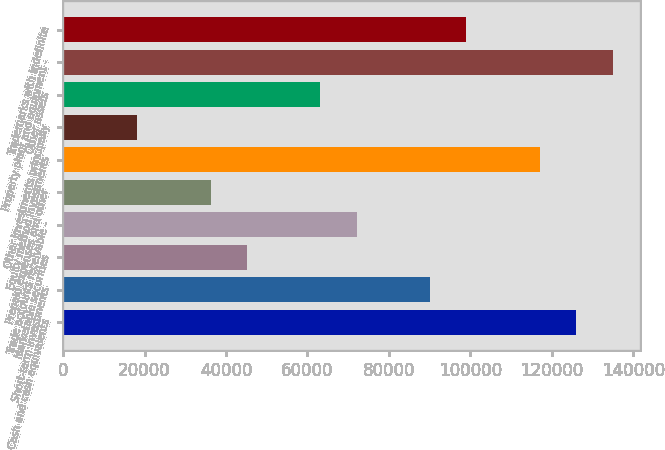<chart> <loc_0><loc_0><loc_500><loc_500><bar_chart><fcel>Cash and cash equivalents<fcel>Short-term investments<fcel>Marketable securities<fcel>Trade accounts receivable -<fcel>Prepaid expenses and other<fcel>Equity method investments<fcel>Other investments principally<fcel>Other assets<fcel>Property plant and equipment -<fcel>Trademarks with indefinite<nl><fcel>125953<fcel>90055<fcel>45182<fcel>72105.8<fcel>36207.4<fcel>116979<fcel>18258.2<fcel>63131.2<fcel>134928<fcel>99029.6<nl></chart> 